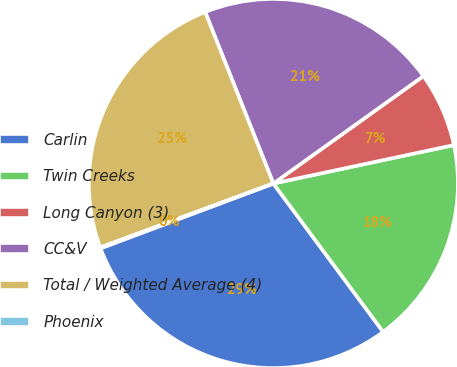Convert chart to OTSL. <chart><loc_0><loc_0><loc_500><loc_500><pie_chart><fcel>Carlin<fcel>Twin Creeks<fcel>Long Canyon (3)<fcel>CC&V<fcel>Total / Weighted Average (4)<fcel>Phoenix<nl><fcel>29.43%<fcel>18.2%<fcel>6.55%<fcel>21.14%<fcel>24.61%<fcel>0.08%<nl></chart> 